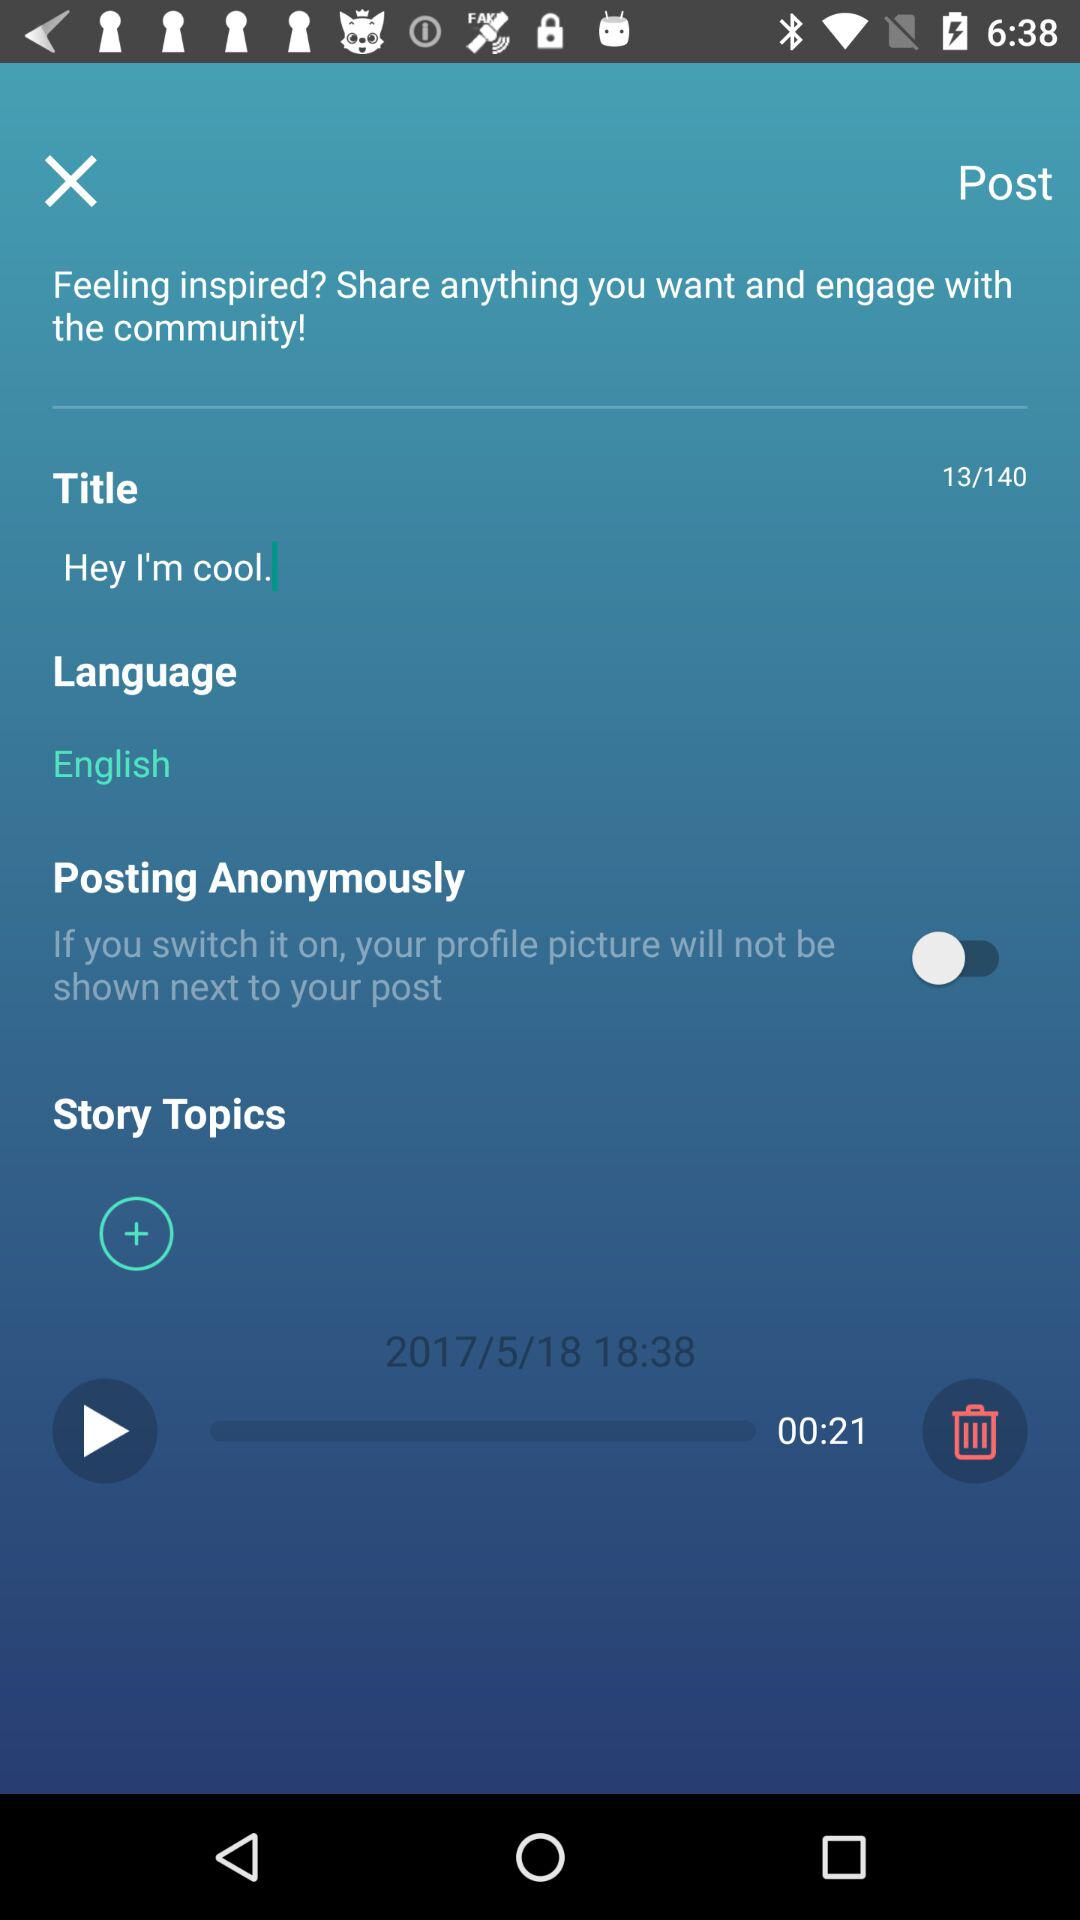What is the time? The time is 18:38. 